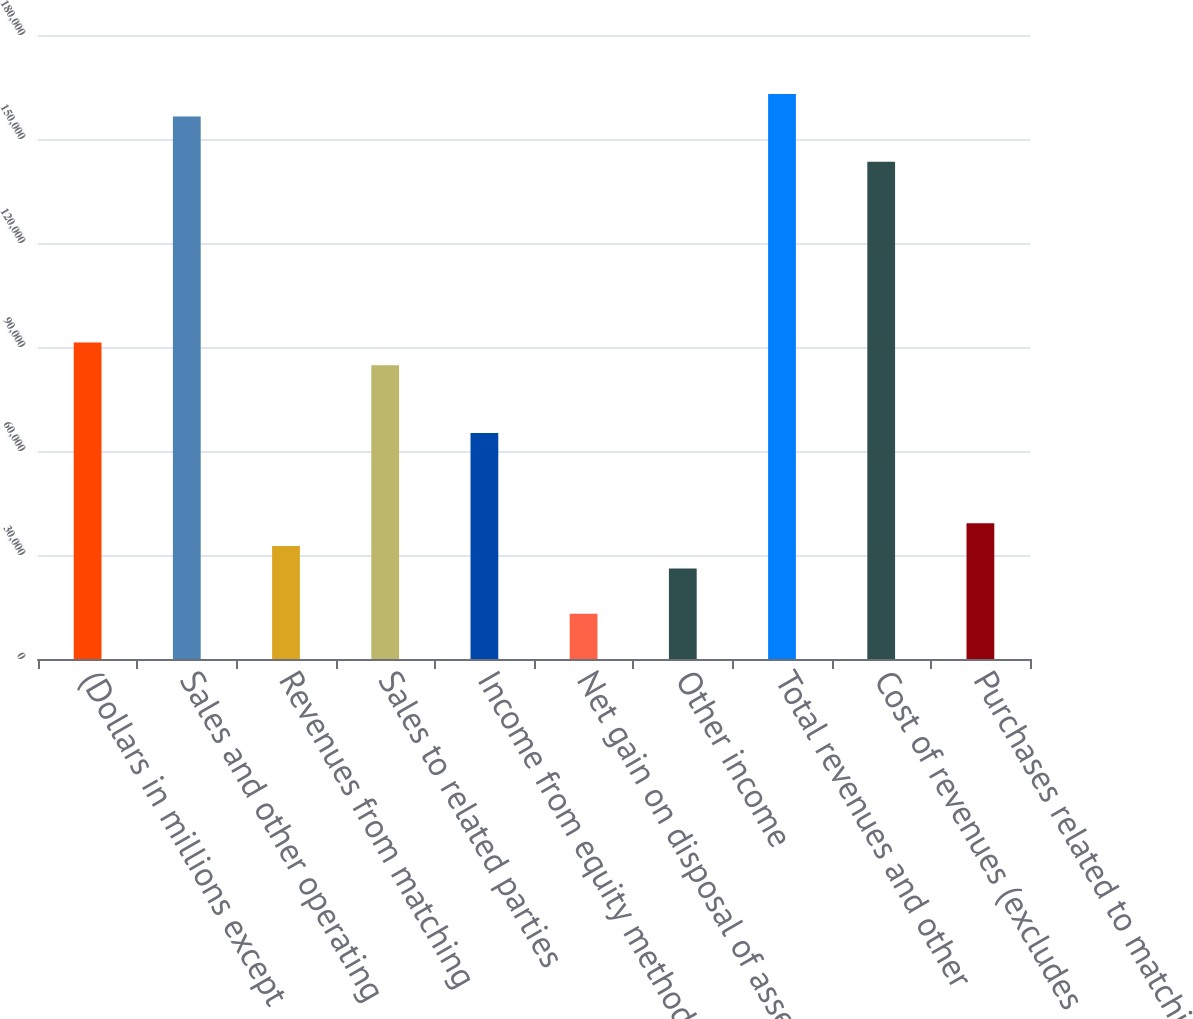<chart> <loc_0><loc_0><loc_500><loc_500><bar_chart><fcel>(Dollars in millions except<fcel>Sales and other operating<fcel>Revenues from matching<fcel>Sales to related parties<fcel>Income from equity method<fcel>Net gain on disposal of assets<fcel>Other income<fcel>Total revenues and other<fcel>Cost of revenues (excludes<fcel>Purchases related to matching<nl><fcel>91288.6<fcel>156493<fcel>32605<fcel>84768.2<fcel>65207<fcel>13043.8<fcel>26084.6<fcel>163013<fcel>143452<fcel>39125.4<nl></chart> 